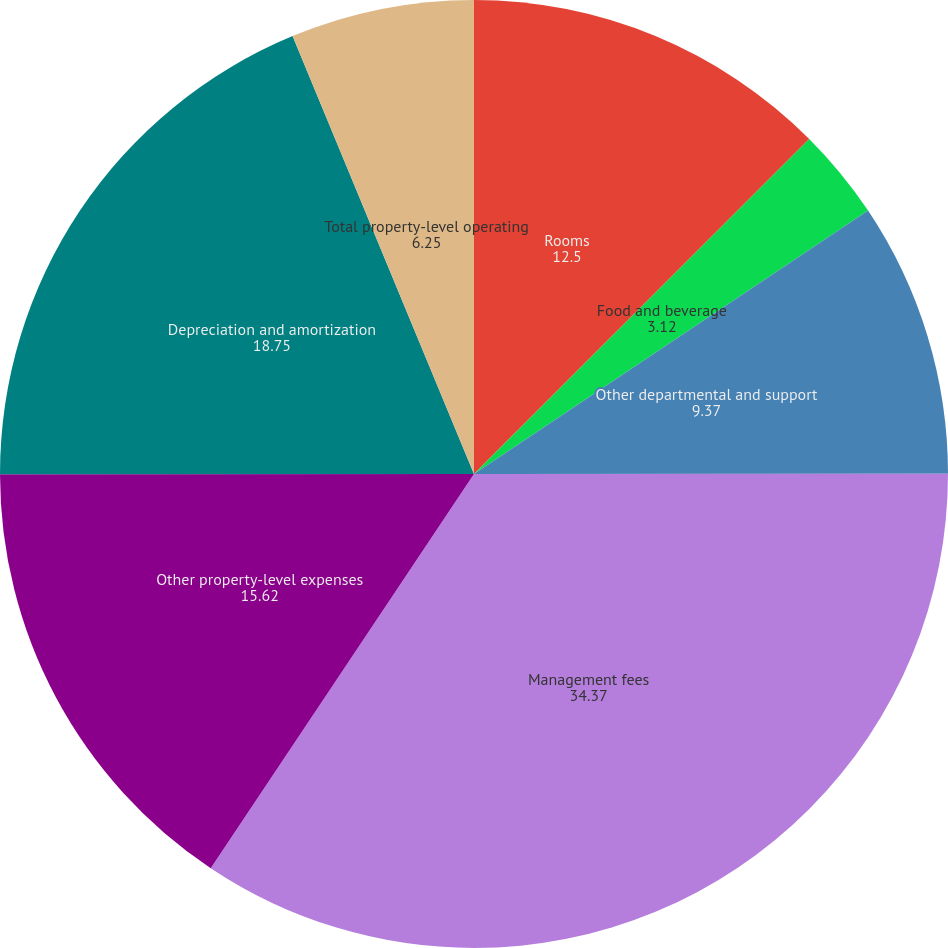Convert chart. <chart><loc_0><loc_0><loc_500><loc_500><pie_chart><fcel>Rooms<fcel>Food and beverage<fcel>Other departmental and support<fcel>Management fees<fcel>Other property-level expenses<fcel>Depreciation and amortization<fcel>Total property-level operating<nl><fcel>12.5%<fcel>3.12%<fcel>9.37%<fcel>34.37%<fcel>15.62%<fcel>18.75%<fcel>6.25%<nl></chart> 